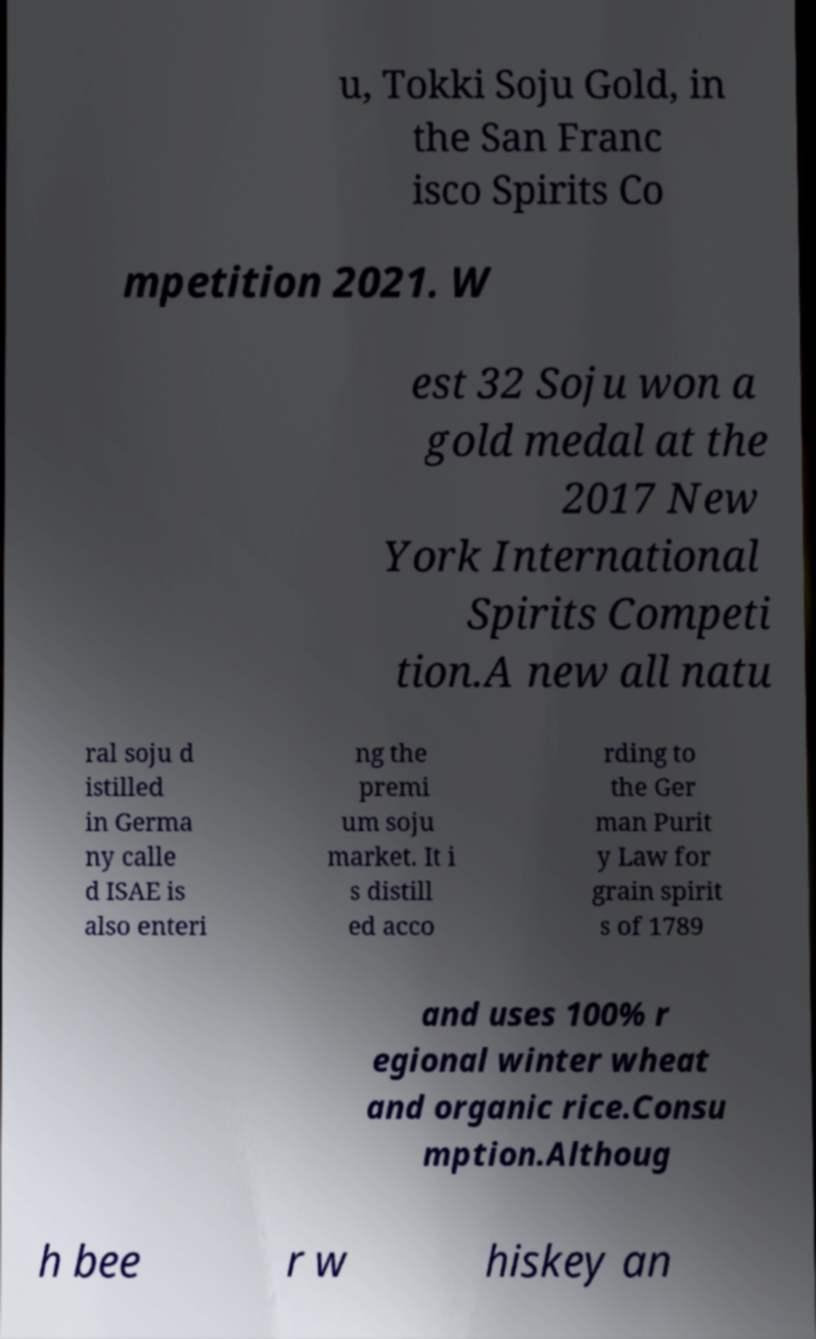Could you extract and type out the text from this image? u, Tokki Soju Gold, in the San Franc isco Spirits Co mpetition 2021. W est 32 Soju won a gold medal at the 2017 New York International Spirits Competi tion.A new all natu ral soju d istilled in Germa ny calle d ISAE is also enteri ng the premi um soju market. It i s distill ed acco rding to the Ger man Purit y Law for grain spirit s of 1789 and uses 100% r egional winter wheat and organic rice.Consu mption.Althoug h bee r w hiskey an 